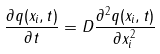<formula> <loc_0><loc_0><loc_500><loc_500>\frac { \partial q ( x _ { i } , t ) } { \partial t } = D \frac { \partial ^ { 2 } q ( x _ { i } , t ) } { \partial x _ { i } ^ { 2 } }</formula> 